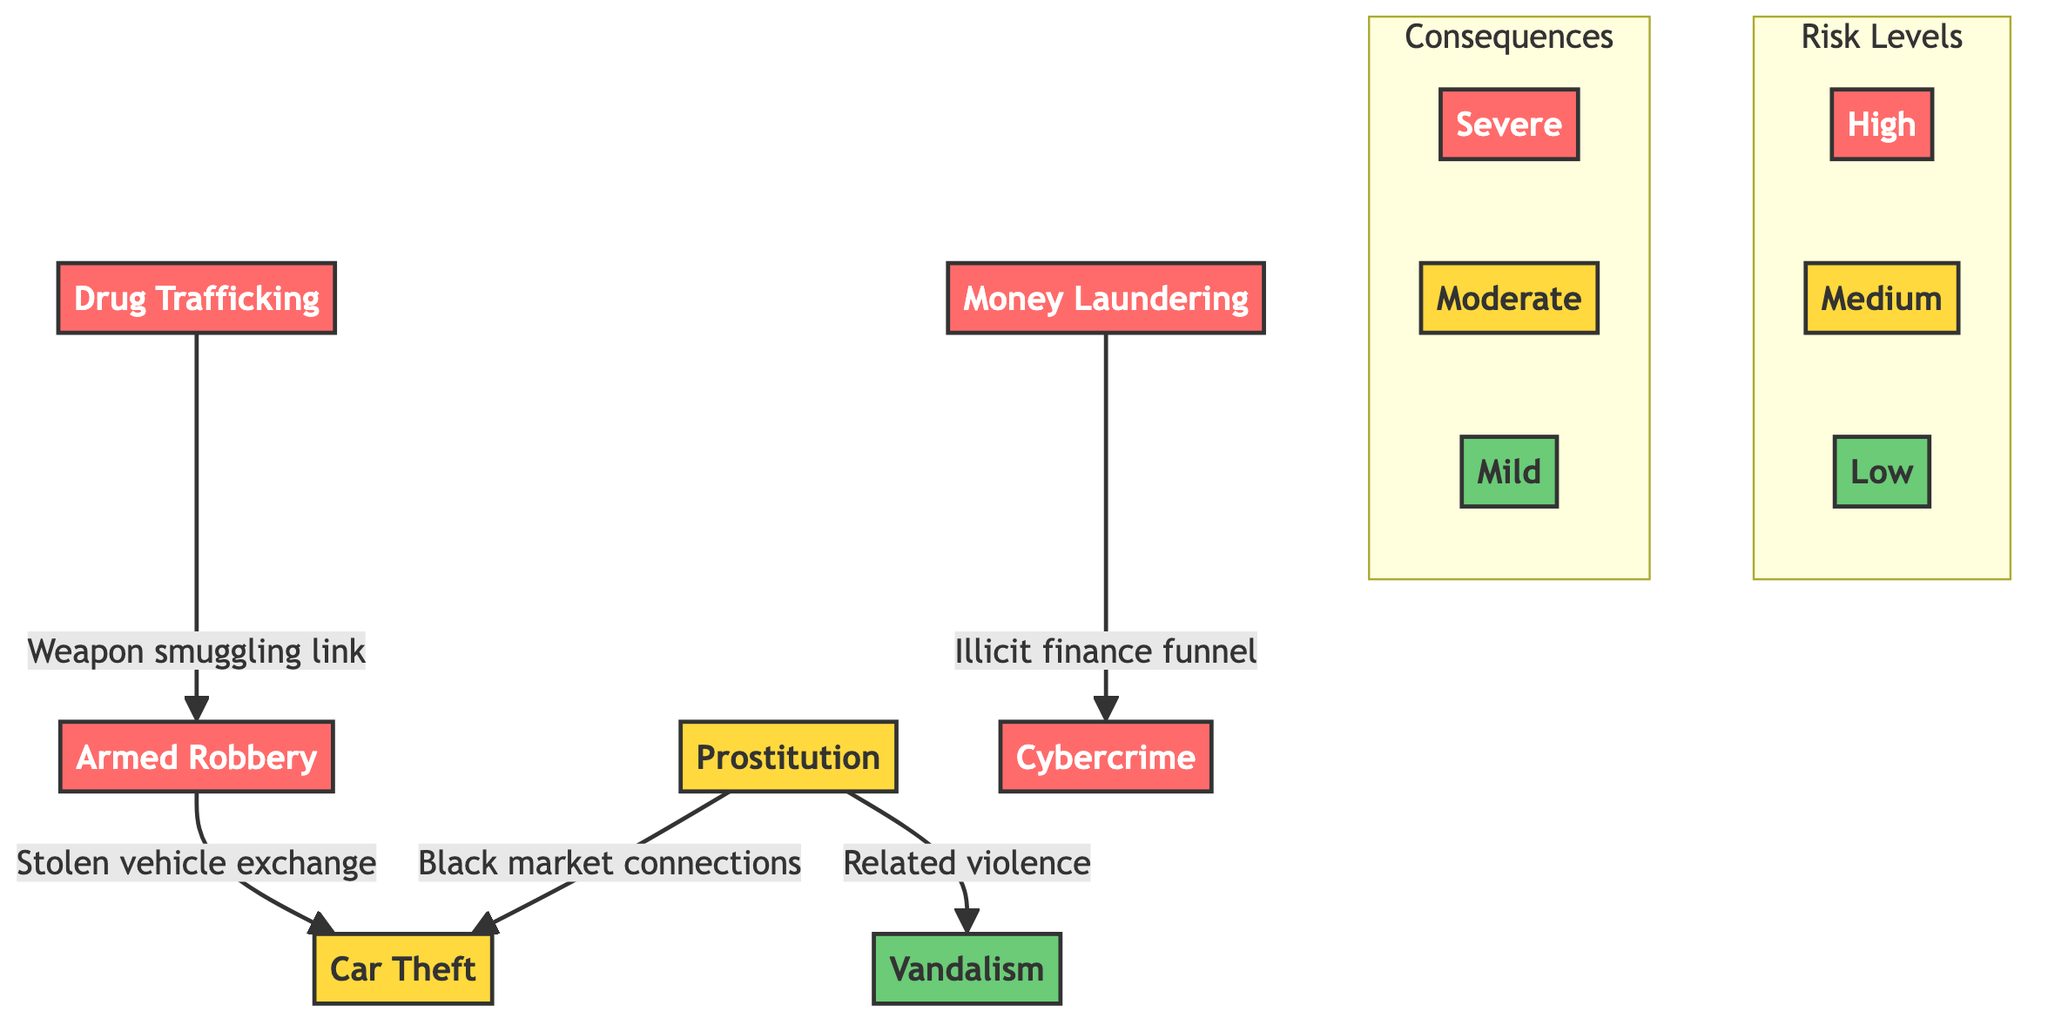What is the risk level of armed robbery? The diagram indicates that armed robbery is categorized under the "High" risk level section.
Answer: High Which activity is associated with mild consequences? Referring to the diagram, vandalism is listed under the "Mild" consequences category.
Answer: Vandalism How many activities are classified as high risk? By counting the activities in the high-risk section of the diagram, we find that there are four activities listed: drug trafficking, armed robbery, money laundering, and cybercrime.
Answer: 4 What kind of connection exists between drug trafficking and armed robbery? The diagram shows a direct link denoted as "Weapon smuggling link" between drug trafficking and armed robbery.
Answer: Weapon smuggling link Which activity has a moderate risk level and is linked to both prostitution and armed robbery? The risk level of car theft is listed as moderate, and it has connections indicated from both prostitution and armed robbery.
Answer: Car Theft What consequence do both money laundering and cybercrime share? Upon examining the consequences associated with both money laundering and cybercrime, they both lead to severe consequences as they are under the "Severe" category.
Answer: Severe Identify the lowest risk activity in the diagram. The diagram marks vandalism as the lowest risk activity, categorized under low risk.
Answer: Vandalism Which two activities are linked through stolen vehicle exchange? The diagram indicates a relationship between armed robbery and car theft through the label "Stolen vehicle exchange."
Answer: Armed Robbery and Car Theft What color represents moderate risk in the diagram? The color representing moderate risk in the diagram is yellow, which is used to signify the medium risk level for certain activities.
Answer: Yellow 